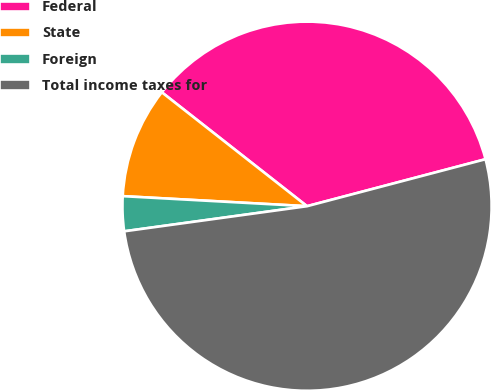Convert chart to OTSL. <chart><loc_0><loc_0><loc_500><loc_500><pie_chart><fcel>Federal<fcel>State<fcel>Foreign<fcel>Total income taxes for<nl><fcel>35.32%<fcel>9.72%<fcel>3.04%<fcel>51.93%<nl></chart> 